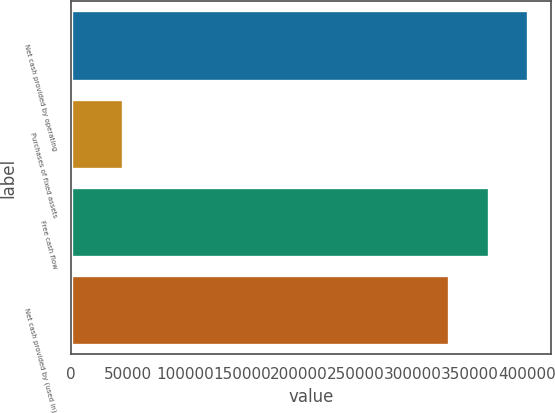Convert chart to OTSL. <chart><loc_0><loc_0><loc_500><loc_500><bar_chart><fcel>Net cash provided by operating<fcel>Purchases of fixed assets<fcel>Free cash flow<fcel>Net cash provided by (used in)<nl><fcel>401198<fcel>45963<fcel>366592<fcel>331986<nl></chart> 